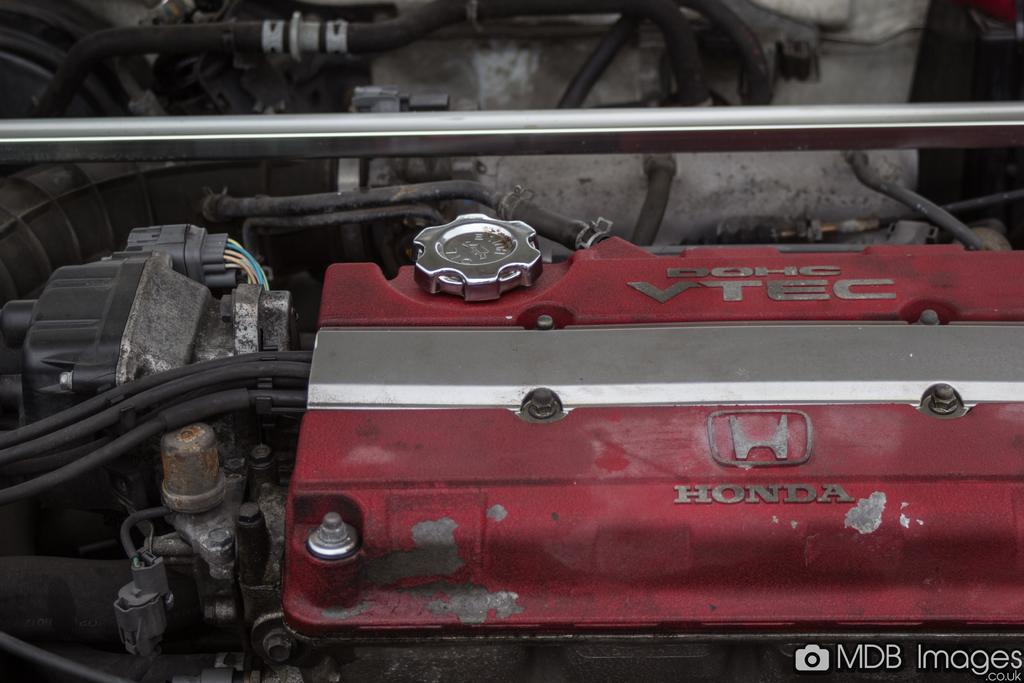What is the main object in the image? There is an engine in the image. Are there any additional features visible in the image? Yes, there are wires visible in the image. Where is the nearest store to the engine in the image? There is no information about the location of a store in the image, as it only features an engine and wires. 